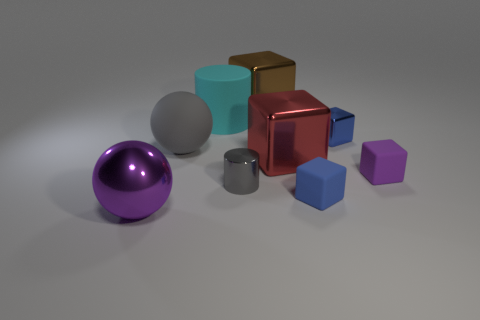What size is the rubber cube that is the same color as the shiny sphere?
Offer a terse response. Small. The big object that is both on the right side of the cyan matte cylinder and on the left side of the red cube has what shape?
Give a very brief answer. Cube. There is a blue rubber object; does it have the same shape as the big object that is in front of the small blue matte cube?
Give a very brief answer. No. There is a big matte cylinder; are there any big metallic objects behind it?
Ensure brevity in your answer.  Yes. There is a block that is the same color as the big metallic sphere; what material is it?
Ensure brevity in your answer.  Rubber. How many blocks are either brown shiny objects or small gray objects?
Offer a very short reply. 1. Do the small blue shiny object and the small purple rubber object have the same shape?
Offer a very short reply. Yes. There is a purple thing on the right side of the cyan matte object; what is its size?
Offer a terse response. Small. Are there any large matte objects of the same color as the tiny cylinder?
Provide a short and direct response. Yes. Is the size of the blue object in front of the red thing the same as the large purple metallic thing?
Ensure brevity in your answer.  No. 